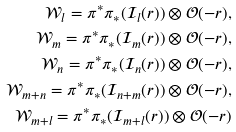<formula> <loc_0><loc_0><loc_500><loc_500>\mathcal { W } _ { l } = \pi ^ { * } \pi _ { * } ( \mathcal { I } _ { l } ( r ) ) \otimes \mathcal { O } ( - r ) , \\ \mathcal { W } _ { m } = \pi ^ { * } \pi _ { * } ( \mathcal { I } _ { m } ( r ) ) \otimes \mathcal { O } ( - r ) , \\ \mathcal { W } _ { n } = \pi ^ { * } \pi _ { * } ( \mathcal { I } _ { n } ( r ) ) \otimes \mathcal { O } ( - r ) , \\ \mathcal { W } _ { m + n } = \pi ^ { * } \pi _ { * } ( \mathcal { I } _ { n + m } ( r ) ) \otimes \mathcal { O } ( - r ) , \\ \mathcal { W } _ { m + l } = \pi ^ { * } \pi _ { * } ( \mathcal { I } _ { m + l } ( r ) ) \otimes \mathcal { O } ( - r )</formula> 